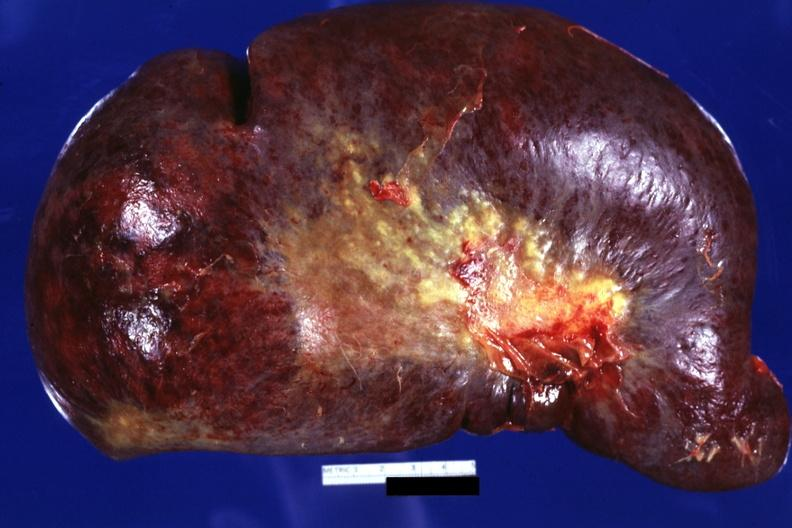does metastatic lung carcinoma show external view huge spleen?
Answer the question using a single word or phrase. No 